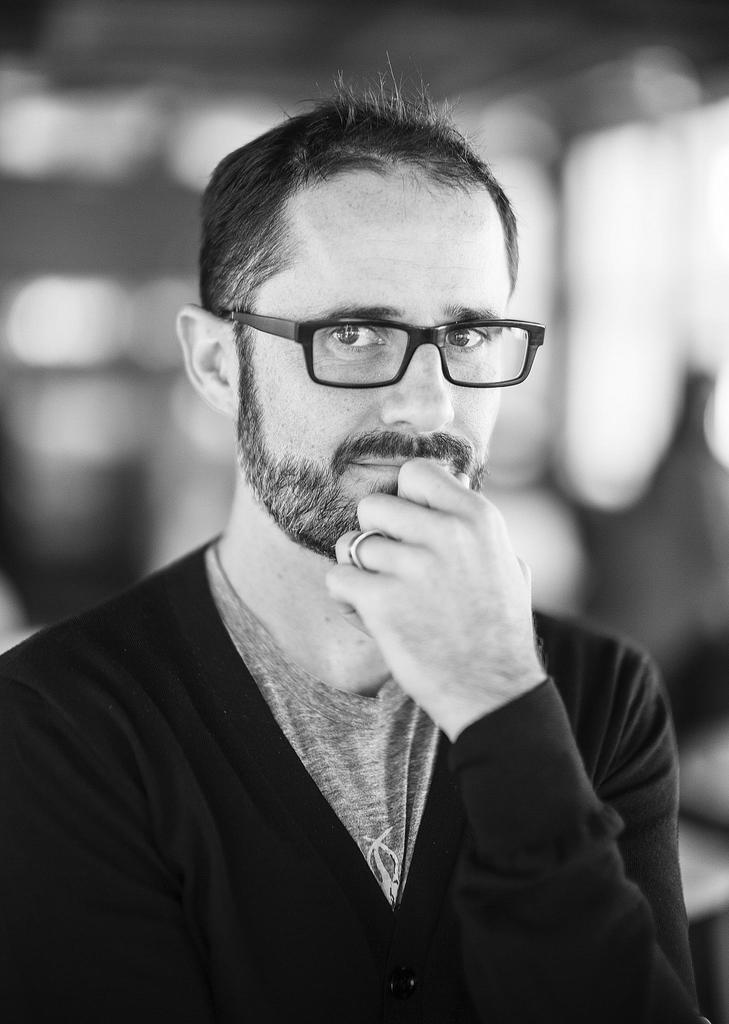Who is present in the image? There is a man in the image. What accessory is the man wearing in the image? The man is wearing glasses in the image. What type of goldfish can be seen swimming in the image? There are no goldfish present in the image; it features a man wearing glasses. What kind of music is being played in the background of the image? There is no music present in the image; it only features a man wearing glasses. 